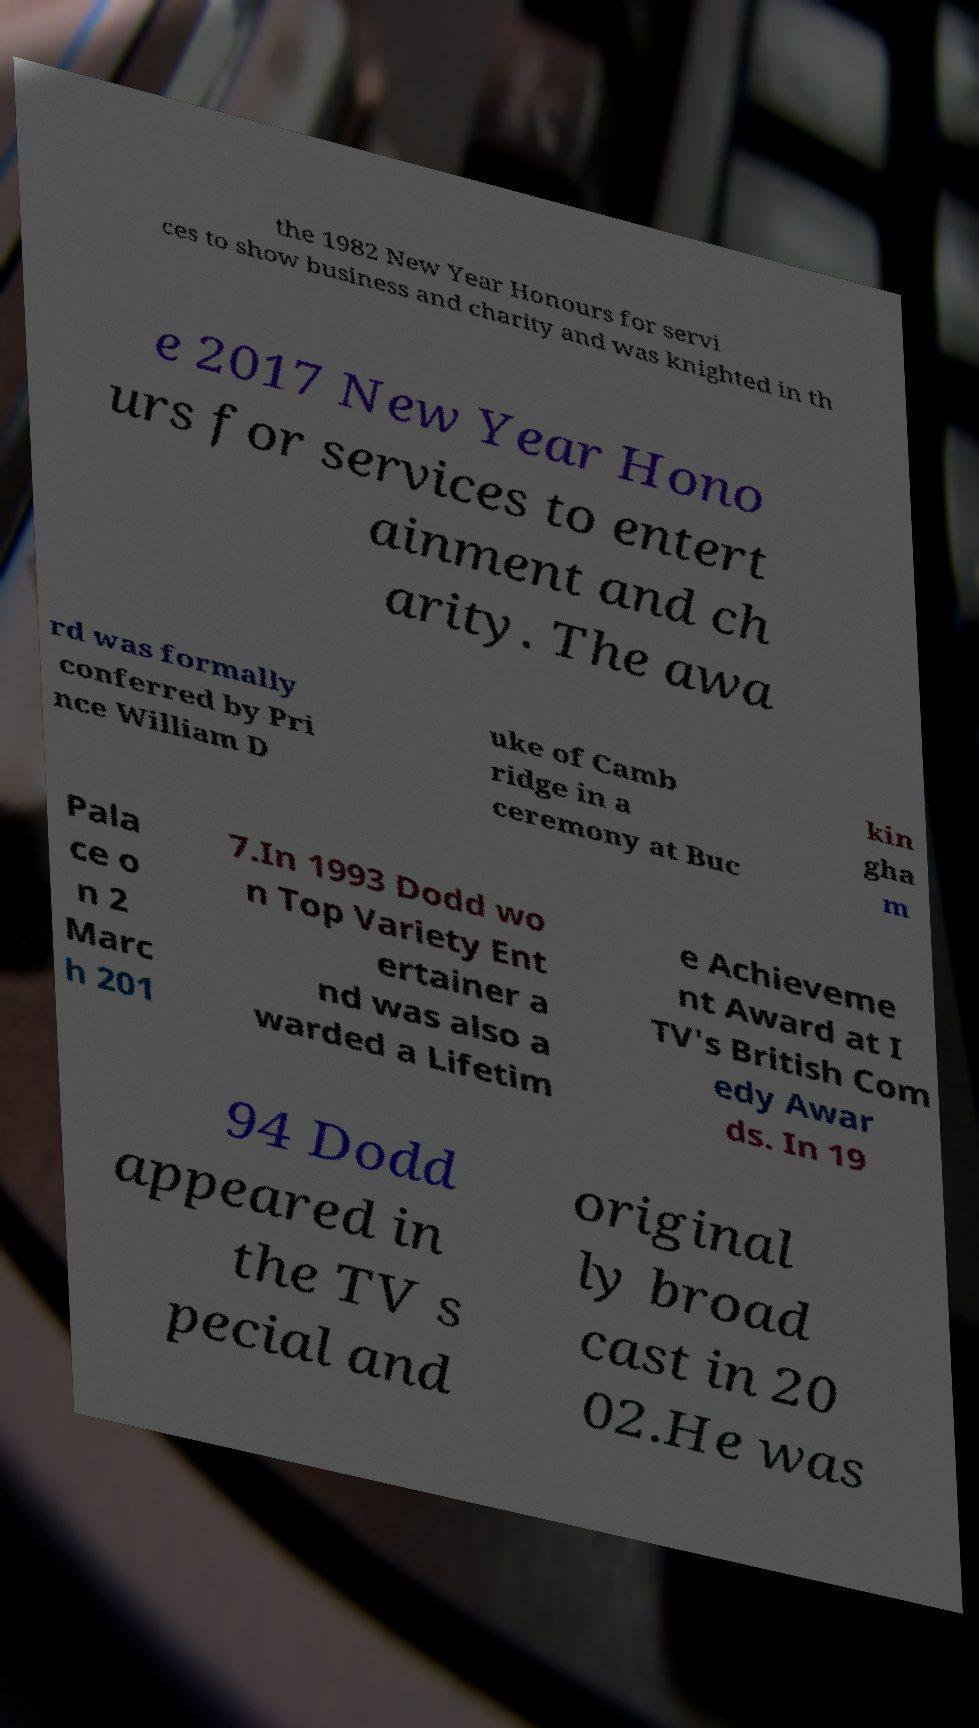Could you assist in decoding the text presented in this image and type it out clearly? the 1982 New Year Honours for servi ces to show business and charity and was knighted in th e 2017 New Year Hono urs for services to entert ainment and ch arity. The awa rd was formally conferred by Pri nce William D uke of Camb ridge in a ceremony at Buc kin gha m Pala ce o n 2 Marc h 201 7.In 1993 Dodd wo n Top Variety Ent ertainer a nd was also a warded a Lifetim e Achieveme nt Award at I TV's British Com edy Awar ds. In 19 94 Dodd appeared in the TV s pecial and original ly broad cast in 20 02.He was 